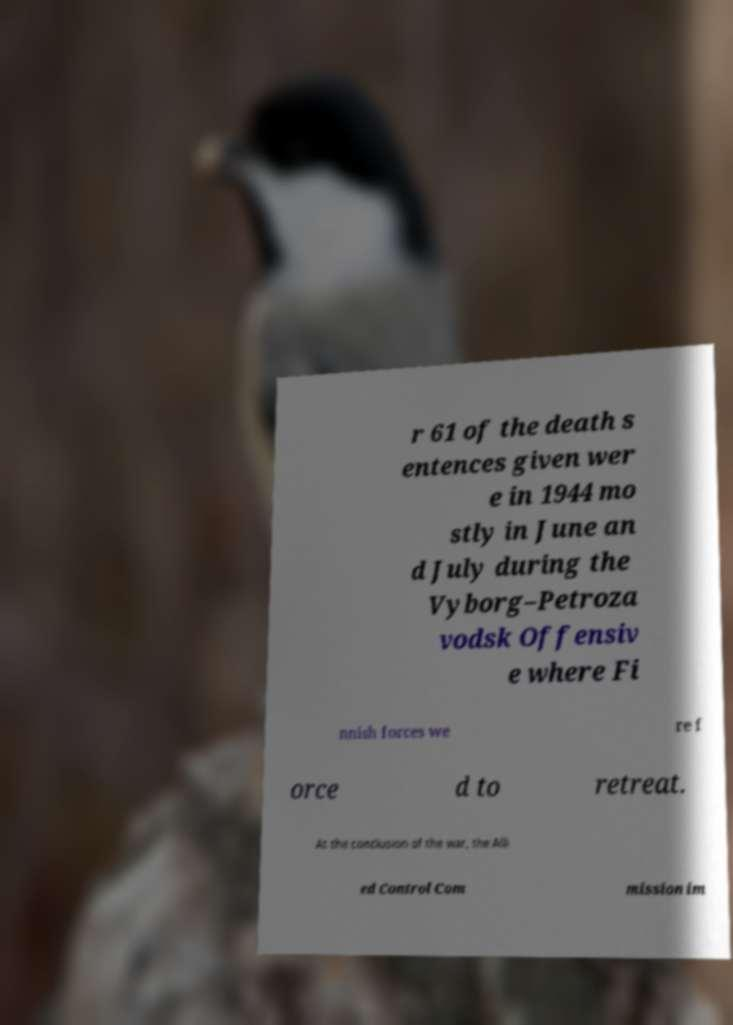Can you accurately transcribe the text from the provided image for me? r 61 of the death s entences given wer e in 1944 mo stly in June an d July during the Vyborg–Petroza vodsk Offensiv e where Fi nnish forces we re f orce d to retreat. At the conclusion of the war, the Alli ed Control Com mission im 